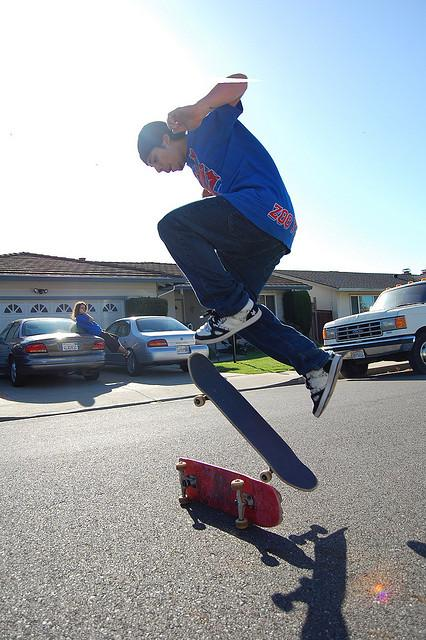What type of skateboarding would this be considered? trick 